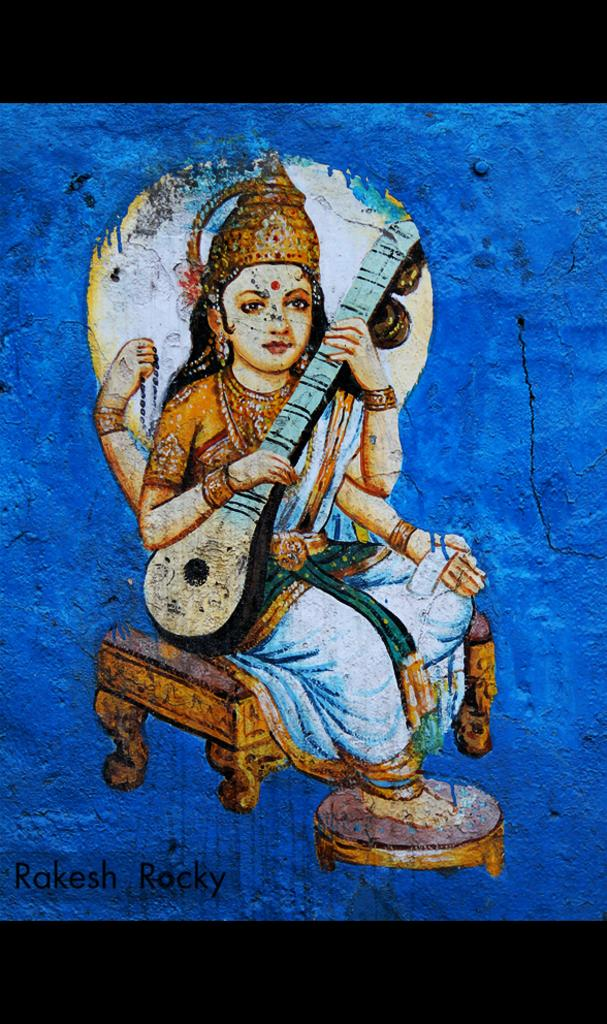Who is the main subject in the image? There is a woman in the image. What is the woman doing in the image? The woman is painting on a wall. What else is the woman holding in the image? The woman is holding a guitar. What additional information can be found at the bottom of the image? There is text written at the bottom of the image. What type of ghost can be seen interacting with the woman in the image? There is no ghost present in the image; it only features a woman painting on a wall and holding a guitar. How does the woman's behavior change when she sees a quince in the image? There is no quince present in the image, so it is not possible to determine how the woman's behavior would change in response to it. 